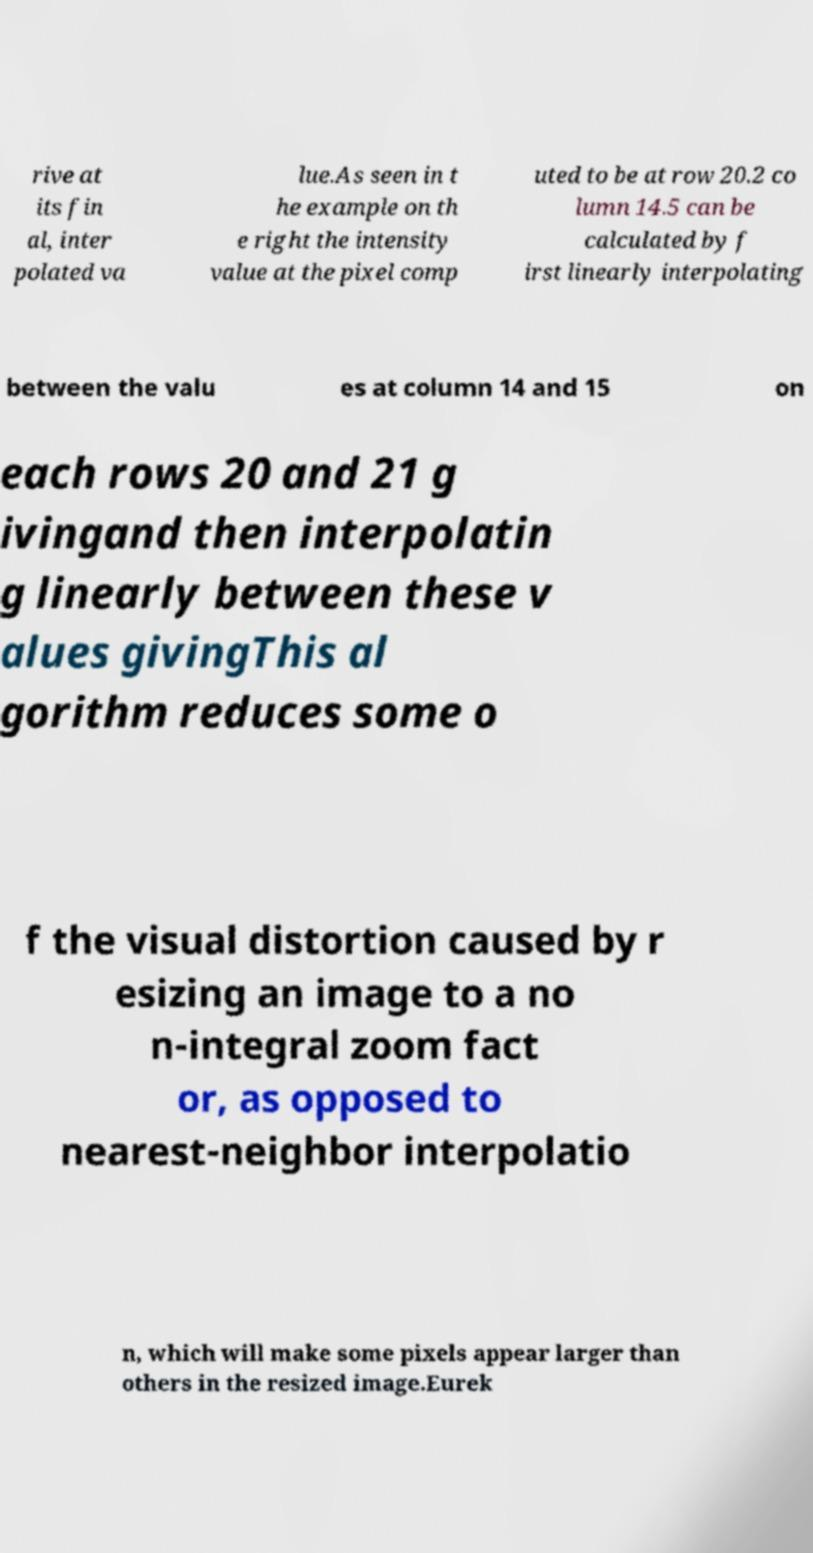For documentation purposes, I need the text within this image transcribed. Could you provide that? rive at its fin al, inter polated va lue.As seen in t he example on th e right the intensity value at the pixel comp uted to be at row 20.2 co lumn 14.5 can be calculated by f irst linearly interpolating between the valu es at column 14 and 15 on each rows 20 and 21 g ivingand then interpolatin g linearly between these v alues givingThis al gorithm reduces some o f the visual distortion caused by r esizing an image to a no n-integral zoom fact or, as opposed to nearest-neighbor interpolatio n, which will make some pixels appear larger than others in the resized image.Eurek 